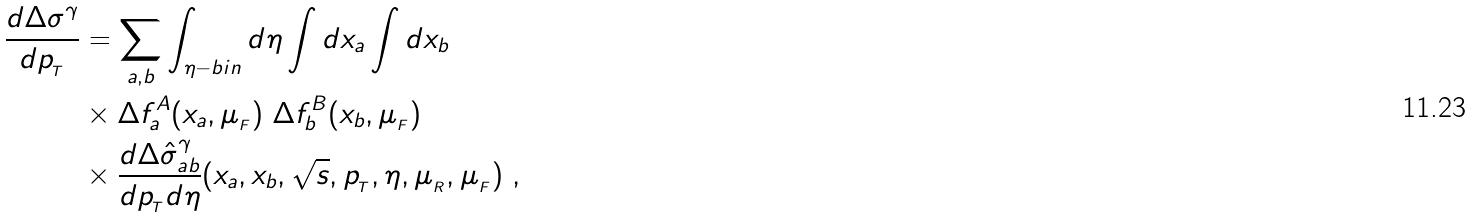<formula> <loc_0><loc_0><loc_500><loc_500>\frac { d \Delta \sigma ^ { \gamma } } { d p _ { _ { T } } } & = \sum _ { a , b } \int _ { \eta - b i n } d \eta \int d x _ { a } \int d x _ { b } \\ & \times \Delta f _ { a } ^ { A } ( x _ { a } , \mu _ { _ { F } } ) \ \Delta f _ { b } ^ { B } ( x _ { b } , \mu _ { _ { F } } ) \\ & \times \frac { d \Delta \hat { \sigma } _ { a b } ^ { \gamma } } { d p _ { _ { T } } d \eta } ( x _ { a } , x _ { b } , \sqrt { s } , p _ { _ { T } } , \eta , \mu _ { _ { R } } , \mu _ { _ { F } } ) \ ,</formula> 